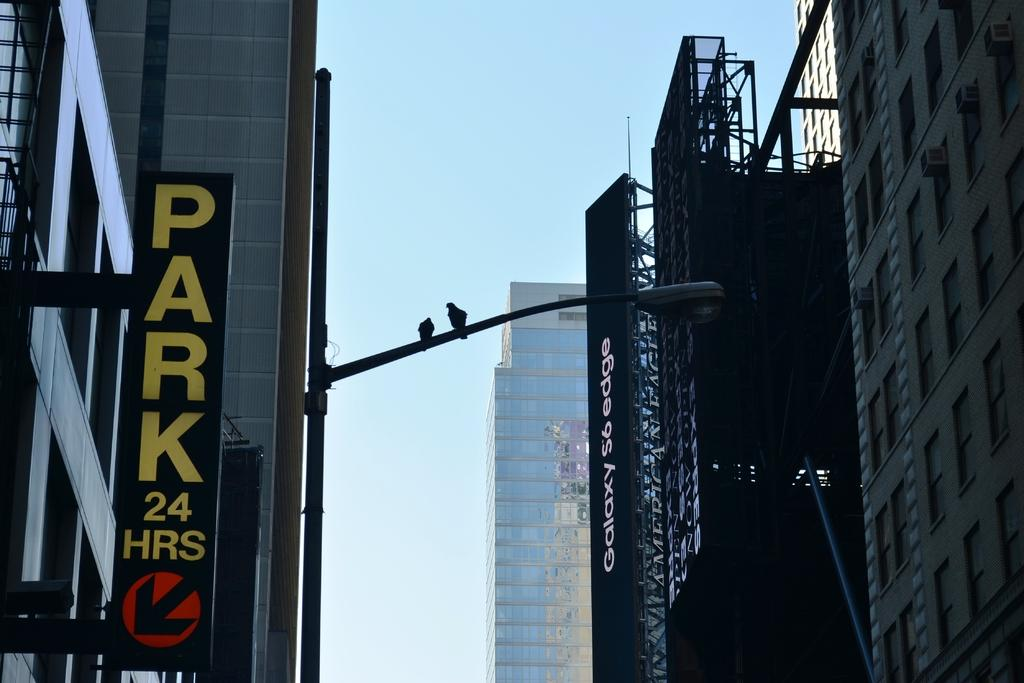What type of structures can be seen in the image? There are buildings in the image. What is the large sign with advertisements or messages called in the image? There is a hoarding in the image. What type of object is used to provide illumination at night on the street? There is a street light pole in the image. Are there any animals visible in the image? Yes, two birds are sitting on the street light pole. What type of toy can be seen playing with the fang in the image? There is no toy or fang present in the image. What sound can be heard coming from the birds in the image? The image is silent, so no sounds can be heard. 